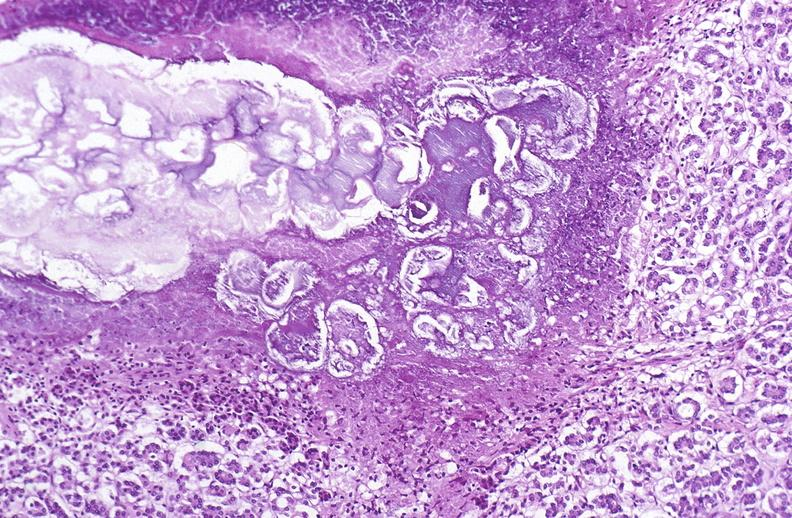does lip show pancreatic fat necrosis?
Answer the question using a single word or phrase. No 